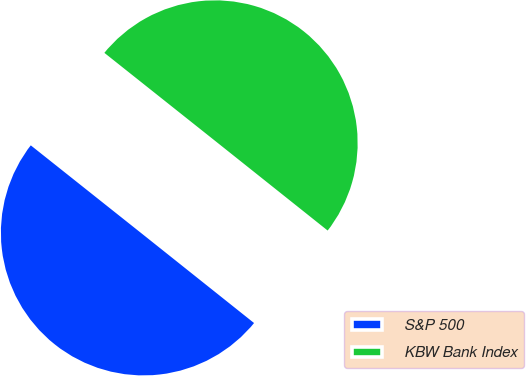<chart> <loc_0><loc_0><loc_500><loc_500><pie_chart><fcel>S&P 500<fcel>KBW Bank Index<nl><fcel>49.98%<fcel>50.02%<nl></chart> 